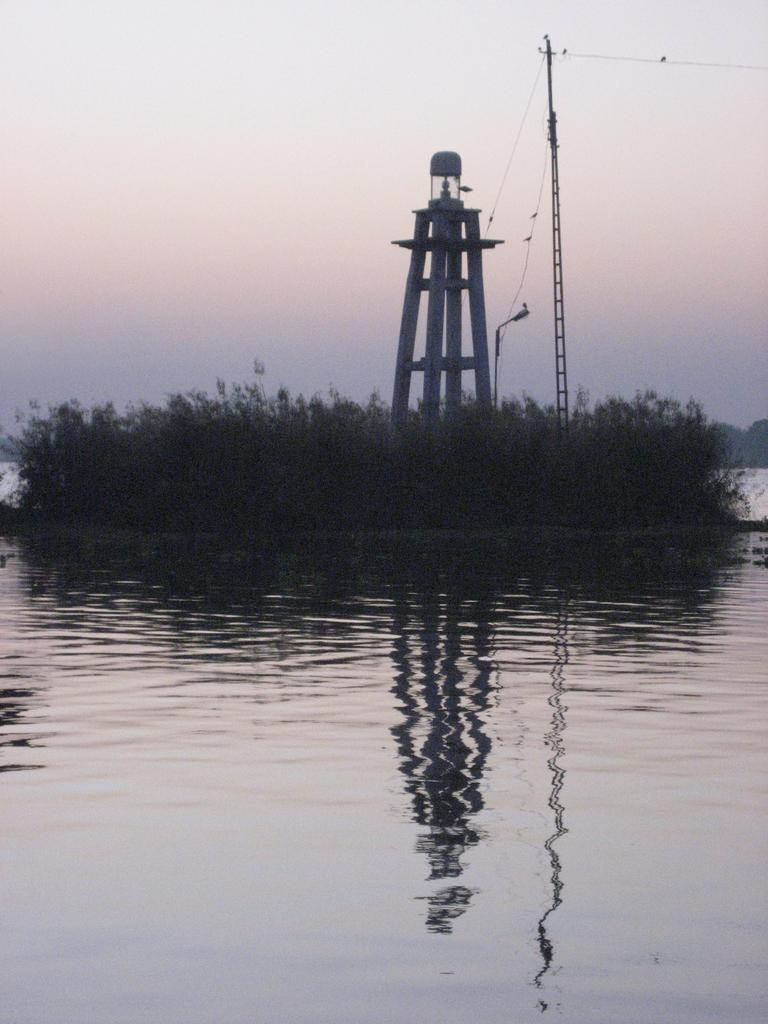What is the main structure in the center of the image? There is a tower in the center of the image. What else is present in the center of the image? There is a pole and plants in the center of the image. What can be seen at the bottom of the image? There is water visible at the bottom of the image. What is visible in the background of the image? The sky is visible in the background of the image. What type of cream can be seen bursting out of the tower in the image? There is no cream or bursting in the image; it features a tower, pole, plants, water, and sky. 